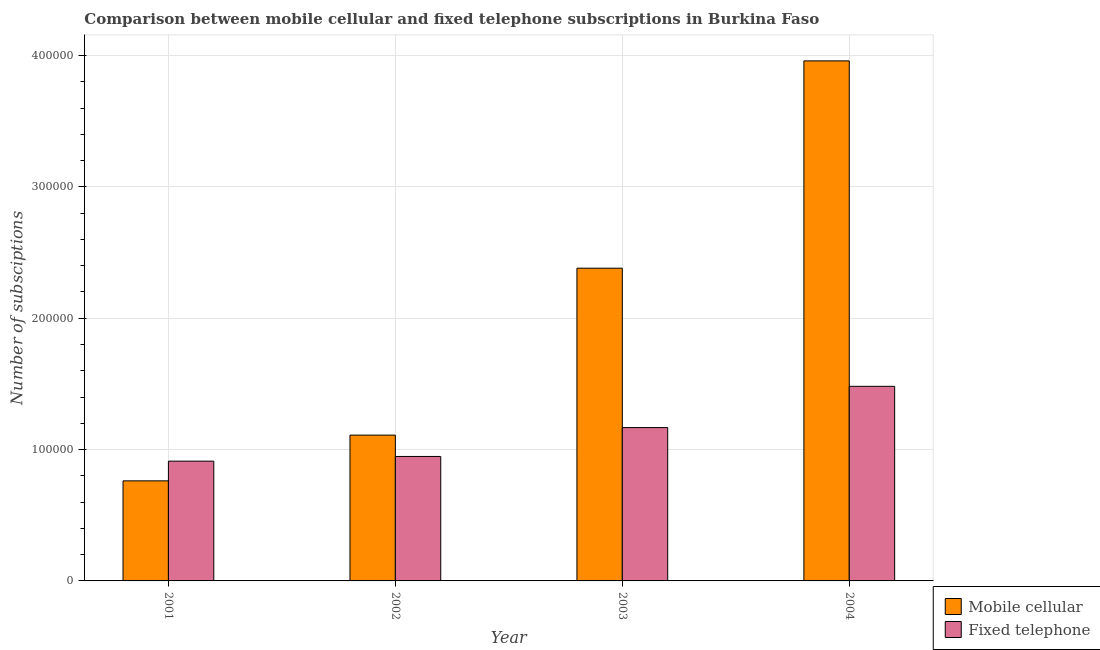How many groups of bars are there?
Provide a short and direct response. 4. How many bars are there on the 1st tick from the right?
Your answer should be very brief. 2. In how many cases, is the number of bars for a given year not equal to the number of legend labels?
Your response must be concise. 0. What is the number of mobile cellular subscriptions in 2001?
Offer a very short reply. 7.62e+04. Across all years, what is the maximum number of mobile cellular subscriptions?
Your response must be concise. 3.96e+05. Across all years, what is the minimum number of mobile cellular subscriptions?
Ensure brevity in your answer.  7.62e+04. In which year was the number of mobile cellular subscriptions maximum?
Keep it short and to the point. 2004. What is the total number of fixed telephone subscriptions in the graph?
Keep it short and to the point. 4.51e+05. What is the difference between the number of mobile cellular subscriptions in 2001 and that in 2002?
Offer a very short reply. -3.48e+04. What is the difference between the number of mobile cellular subscriptions in 2001 and the number of fixed telephone subscriptions in 2004?
Keep it short and to the point. -3.20e+05. What is the average number of fixed telephone subscriptions per year?
Give a very brief answer. 1.13e+05. In the year 2003, what is the difference between the number of mobile cellular subscriptions and number of fixed telephone subscriptions?
Offer a very short reply. 0. In how many years, is the number of fixed telephone subscriptions greater than 240000?
Ensure brevity in your answer.  0. What is the ratio of the number of mobile cellular subscriptions in 2002 to that in 2004?
Offer a terse response. 0.28. Is the difference between the number of mobile cellular subscriptions in 2002 and 2004 greater than the difference between the number of fixed telephone subscriptions in 2002 and 2004?
Make the answer very short. No. What is the difference between the highest and the second highest number of fixed telephone subscriptions?
Keep it short and to the point. 3.14e+04. What is the difference between the highest and the lowest number of mobile cellular subscriptions?
Give a very brief answer. 3.20e+05. What does the 1st bar from the left in 2001 represents?
Give a very brief answer. Mobile cellular. What does the 2nd bar from the right in 2004 represents?
Keep it short and to the point. Mobile cellular. Are all the bars in the graph horizontal?
Your answer should be very brief. No. What is the difference between two consecutive major ticks on the Y-axis?
Your response must be concise. 1.00e+05. Does the graph contain grids?
Offer a terse response. Yes. What is the title of the graph?
Your answer should be very brief. Comparison between mobile cellular and fixed telephone subscriptions in Burkina Faso. What is the label or title of the Y-axis?
Your response must be concise. Number of subsciptions. What is the Number of subsciptions of Mobile cellular in 2001?
Provide a short and direct response. 7.62e+04. What is the Number of subsciptions of Fixed telephone in 2001?
Provide a succinct answer. 9.12e+04. What is the Number of subsciptions in Mobile cellular in 2002?
Your answer should be compact. 1.11e+05. What is the Number of subsciptions of Fixed telephone in 2002?
Offer a terse response. 9.48e+04. What is the Number of subsciptions in Mobile cellular in 2003?
Provide a succinct answer. 2.38e+05. What is the Number of subsciptions of Fixed telephone in 2003?
Provide a short and direct response. 1.17e+05. What is the Number of subsciptions of Mobile cellular in 2004?
Your answer should be compact. 3.96e+05. What is the Number of subsciptions of Fixed telephone in 2004?
Your answer should be very brief. 1.48e+05. Across all years, what is the maximum Number of subsciptions in Mobile cellular?
Your response must be concise. 3.96e+05. Across all years, what is the maximum Number of subsciptions of Fixed telephone?
Provide a short and direct response. 1.48e+05. Across all years, what is the minimum Number of subsciptions of Mobile cellular?
Offer a very short reply. 7.62e+04. Across all years, what is the minimum Number of subsciptions of Fixed telephone?
Provide a succinct answer. 9.12e+04. What is the total Number of subsciptions of Mobile cellular in the graph?
Make the answer very short. 8.21e+05. What is the total Number of subsciptions in Fixed telephone in the graph?
Your answer should be very brief. 4.51e+05. What is the difference between the Number of subsciptions in Mobile cellular in 2001 and that in 2002?
Offer a terse response. -3.48e+04. What is the difference between the Number of subsciptions of Fixed telephone in 2001 and that in 2002?
Provide a succinct answer. -3567. What is the difference between the Number of subsciptions of Mobile cellular in 2001 and that in 2003?
Offer a very short reply. -1.62e+05. What is the difference between the Number of subsciptions in Fixed telephone in 2001 and that in 2003?
Your answer should be very brief. -2.56e+04. What is the difference between the Number of subsciptions of Mobile cellular in 2001 and that in 2004?
Provide a short and direct response. -3.20e+05. What is the difference between the Number of subsciptions in Fixed telephone in 2001 and that in 2004?
Your answer should be very brief. -5.70e+04. What is the difference between the Number of subsciptions in Mobile cellular in 2002 and that in 2003?
Keep it short and to the point. -1.27e+05. What is the difference between the Number of subsciptions of Fixed telephone in 2002 and that in 2003?
Give a very brief answer. -2.20e+04. What is the difference between the Number of subsciptions in Mobile cellular in 2002 and that in 2004?
Offer a very short reply. -2.85e+05. What is the difference between the Number of subsciptions in Fixed telephone in 2002 and that in 2004?
Your answer should be compact. -5.34e+04. What is the difference between the Number of subsciptions of Mobile cellular in 2003 and that in 2004?
Ensure brevity in your answer.  -1.58e+05. What is the difference between the Number of subsciptions of Fixed telephone in 2003 and that in 2004?
Offer a terse response. -3.14e+04. What is the difference between the Number of subsciptions in Mobile cellular in 2001 and the Number of subsciptions in Fixed telephone in 2002?
Provide a short and direct response. -1.86e+04. What is the difference between the Number of subsciptions of Mobile cellular in 2001 and the Number of subsciptions of Fixed telephone in 2003?
Your response must be concise. -4.06e+04. What is the difference between the Number of subsciptions of Mobile cellular in 2001 and the Number of subsciptions of Fixed telephone in 2004?
Your response must be concise. -7.20e+04. What is the difference between the Number of subsciptions of Mobile cellular in 2002 and the Number of subsciptions of Fixed telephone in 2003?
Give a very brief answer. -5733. What is the difference between the Number of subsciptions in Mobile cellular in 2002 and the Number of subsciptions in Fixed telephone in 2004?
Your response must be concise. -3.71e+04. What is the difference between the Number of subsciptions of Mobile cellular in 2003 and the Number of subsciptions of Fixed telephone in 2004?
Make the answer very short. 8.99e+04. What is the average Number of subsciptions of Mobile cellular per year?
Give a very brief answer. 2.05e+05. What is the average Number of subsciptions in Fixed telephone per year?
Make the answer very short. 1.13e+05. In the year 2001, what is the difference between the Number of subsciptions in Mobile cellular and Number of subsciptions in Fixed telephone?
Ensure brevity in your answer.  -1.50e+04. In the year 2002, what is the difference between the Number of subsciptions in Mobile cellular and Number of subsciptions in Fixed telephone?
Ensure brevity in your answer.  1.63e+04. In the year 2003, what is the difference between the Number of subsciptions of Mobile cellular and Number of subsciptions of Fixed telephone?
Make the answer very short. 1.21e+05. In the year 2004, what is the difference between the Number of subsciptions of Mobile cellular and Number of subsciptions of Fixed telephone?
Provide a succinct answer. 2.48e+05. What is the ratio of the Number of subsciptions of Mobile cellular in 2001 to that in 2002?
Your answer should be very brief. 0.69. What is the ratio of the Number of subsciptions of Fixed telephone in 2001 to that in 2002?
Your answer should be very brief. 0.96. What is the ratio of the Number of subsciptions of Mobile cellular in 2001 to that in 2003?
Provide a short and direct response. 0.32. What is the ratio of the Number of subsciptions in Fixed telephone in 2001 to that in 2003?
Your answer should be very brief. 0.78. What is the ratio of the Number of subsciptions of Mobile cellular in 2001 to that in 2004?
Give a very brief answer. 0.19. What is the ratio of the Number of subsciptions of Fixed telephone in 2001 to that in 2004?
Make the answer very short. 0.62. What is the ratio of the Number of subsciptions of Mobile cellular in 2002 to that in 2003?
Provide a short and direct response. 0.47. What is the ratio of the Number of subsciptions of Fixed telephone in 2002 to that in 2003?
Your answer should be compact. 0.81. What is the ratio of the Number of subsciptions in Mobile cellular in 2002 to that in 2004?
Offer a terse response. 0.28. What is the ratio of the Number of subsciptions of Fixed telephone in 2002 to that in 2004?
Provide a succinct answer. 0.64. What is the ratio of the Number of subsciptions of Mobile cellular in 2003 to that in 2004?
Your response must be concise. 0.6. What is the ratio of the Number of subsciptions of Fixed telephone in 2003 to that in 2004?
Your response must be concise. 0.79. What is the difference between the highest and the second highest Number of subsciptions of Mobile cellular?
Keep it short and to the point. 1.58e+05. What is the difference between the highest and the second highest Number of subsciptions of Fixed telephone?
Ensure brevity in your answer.  3.14e+04. What is the difference between the highest and the lowest Number of subsciptions of Mobile cellular?
Offer a terse response. 3.20e+05. What is the difference between the highest and the lowest Number of subsciptions in Fixed telephone?
Provide a succinct answer. 5.70e+04. 